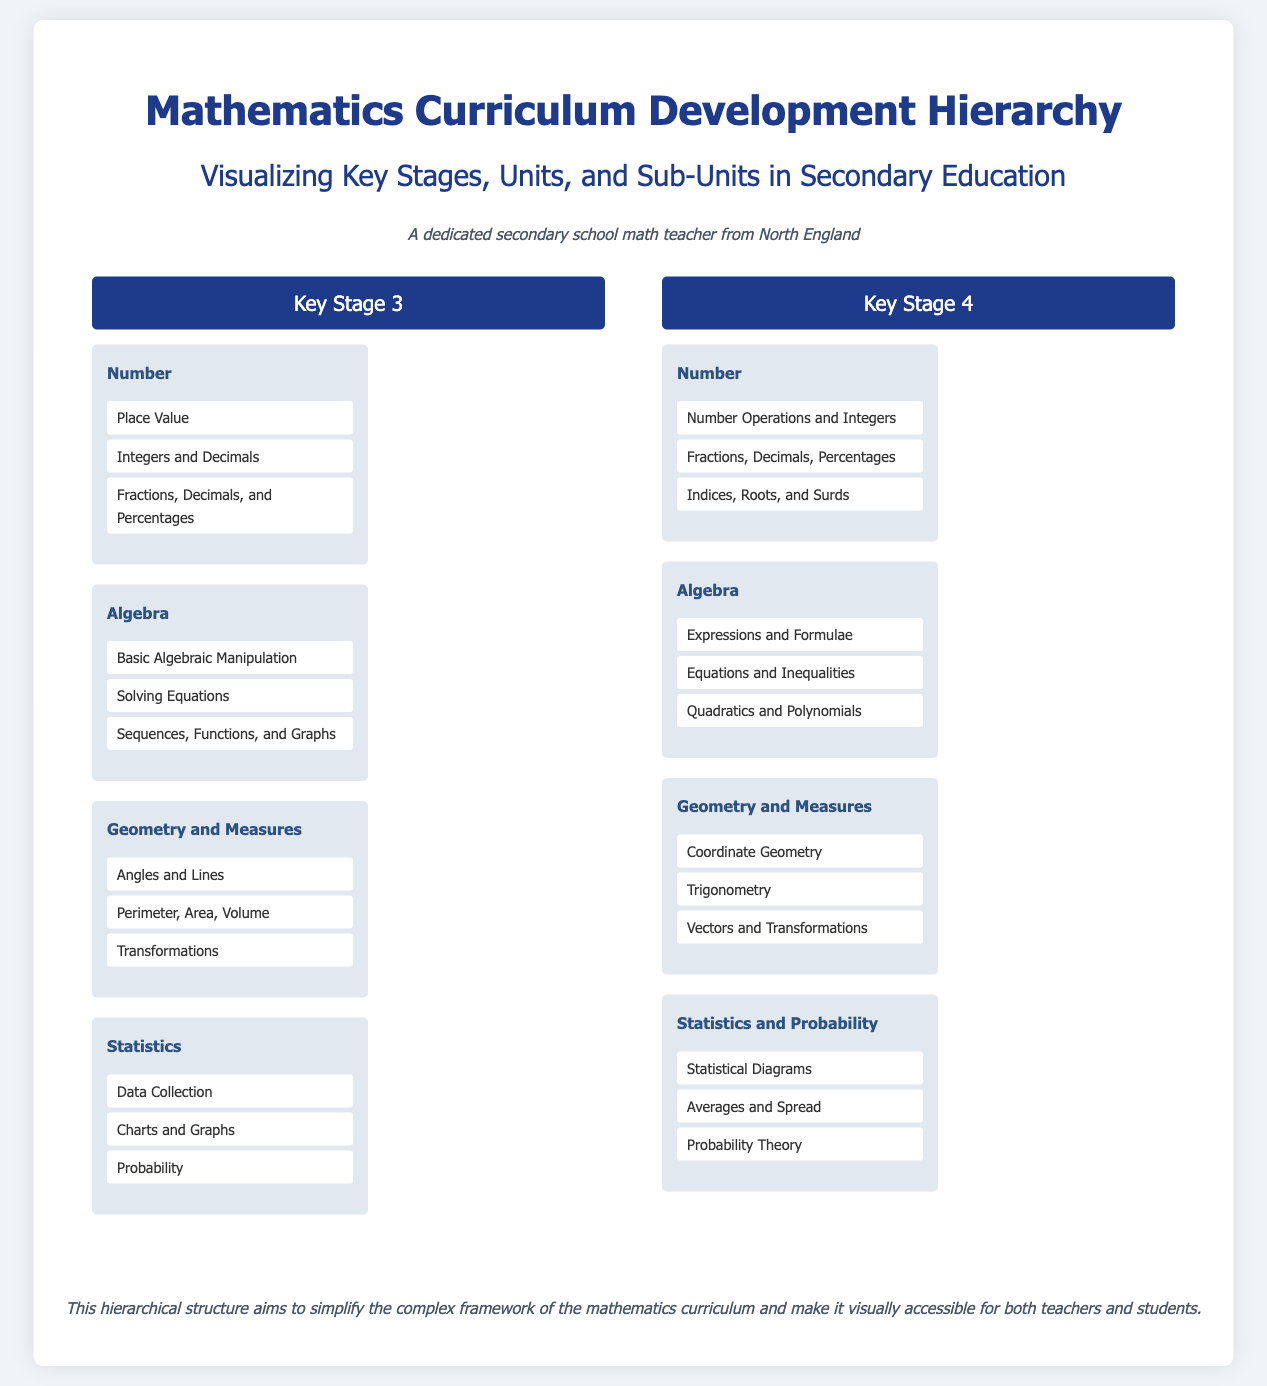What is the title of the document? The title of the document is provided at the top of the hierarchy, indicating the main focus on curricular development.
Answer: Mathematics Curriculum Development Hierarchy How many key stages are presented in the document? The document includes two distinct key stages for the mathematics curriculum, listed with their respective units and sub-units.
Answer: 2 What unit is included in Key Stage 3 that relates to shapes and sizes? This unit covers geometric principles, including dimensions and transformations.
Answer: Geometry and Measures Name a sub-unit under the Statistics unit in Key Stage 3. The sub-units represent foundational topics within the Statistics unit necessary for students' understanding.
Answer: Data Collection Which key stage includes "Quadratics and Polynomials" as a sub-unit? This unit highlights important algebraic concepts necessary for advanced mathematics learning in secondary education.
Answer: Key Stage 4 What is the main purpose of the hierarchical structure in the document? The purpose gives clarity to how the content is organized and facilitates easier comprehension for users of the curriculum.
Answer: Simplify the complex framework Which unit in Key Stage 4 focuses on chance-related topics? This unit combines different elements of data analysis and prediction in mathematics.
Answer: Statistics and Probability How many sub-units are listed under the Algebra unit in Key Stage 4? The document provides direct information on the components under each unit, making them easy to count.
Answer: 3 What color scheme is predominantly used for titles in the document? The design utilizes certain colors to help distinguish sections and titles clearly within the document.
Answer: Dark blue 